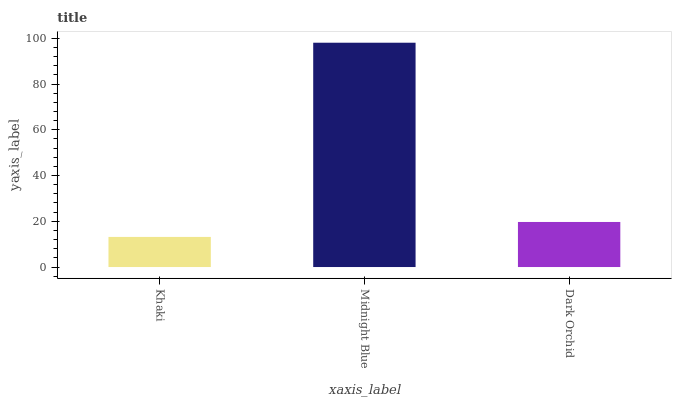Is Khaki the minimum?
Answer yes or no. Yes. Is Midnight Blue the maximum?
Answer yes or no. Yes. Is Dark Orchid the minimum?
Answer yes or no. No. Is Dark Orchid the maximum?
Answer yes or no. No. Is Midnight Blue greater than Dark Orchid?
Answer yes or no. Yes. Is Dark Orchid less than Midnight Blue?
Answer yes or no. Yes. Is Dark Orchid greater than Midnight Blue?
Answer yes or no. No. Is Midnight Blue less than Dark Orchid?
Answer yes or no. No. Is Dark Orchid the high median?
Answer yes or no. Yes. Is Dark Orchid the low median?
Answer yes or no. Yes. Is Khaki the high median?
Answer yes or no. No. Is Khaki the low median?
Answer yes or no. No. 